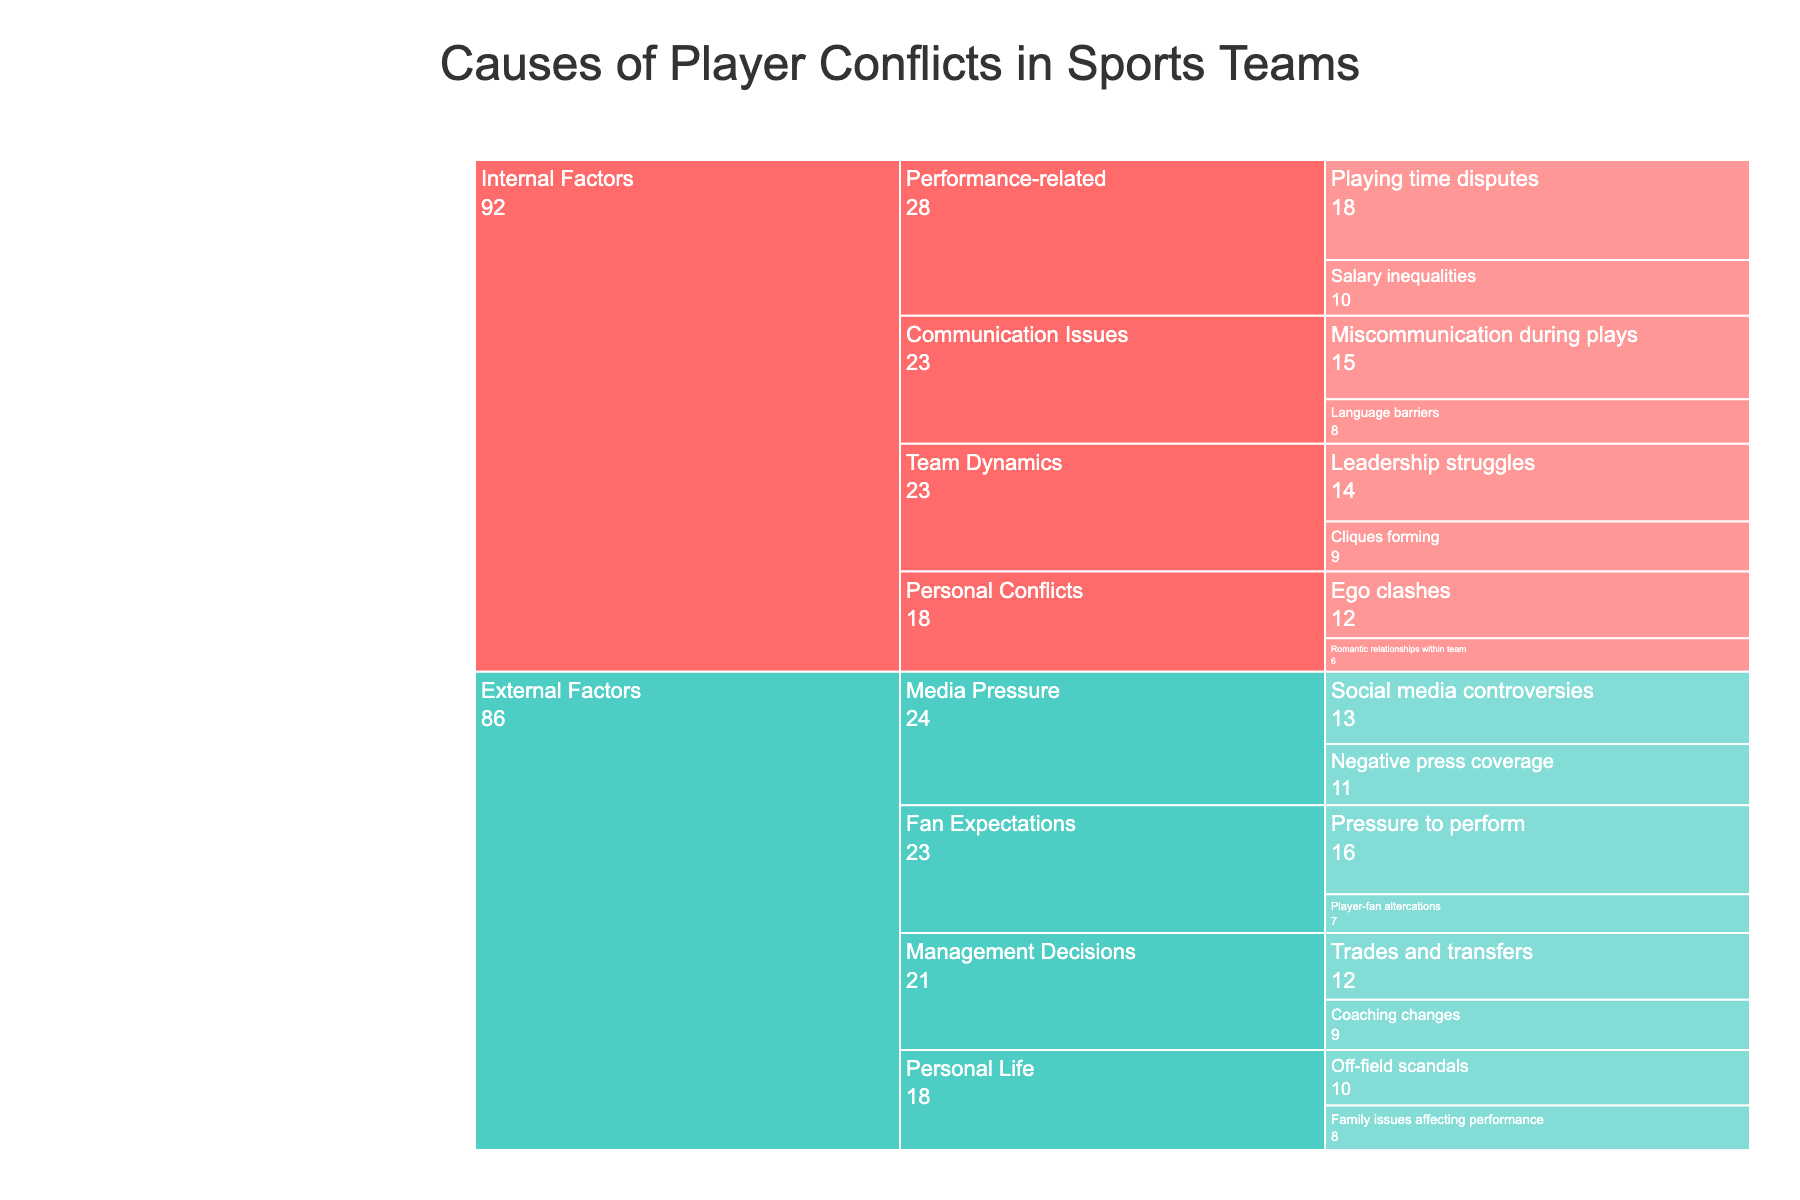What's the title of the figure? The title of the figure is located at the top and is one of the most obvious elements. By looking at the figure, you can easily read the title directly.
Answer: Causes of Player Conflicts in Sports Teams What color represents 'Internal Factors'? The color representation for 'Internal Factors' can be identified by looking at the sections of the icicle chart labeled 'Internal Factors'.
Answer: Red How many data points are under 'Personal Conflicts'? The data points under 'Personal Conflicts' can be counted by identifying the labeled sections and counting each one under that subcategory.
Answer: 2 What is the combined value of 'Non-Communication Issues'? First, identify and sum the values for 'Ego clashes' and 'Romantic relationships within the team'. 12 (Ego clashes) + 6 (Romantic relationships within the team).
Answer: 18 Which factor has the highest value in the chart? Look for the factor with the largest value displayed next to each label in the chart. 'Playing time disputes' under 'Performance-related' in 'Internal Factors' has the highest value.
Answer: Playing time disputes Which subcategory under 'External Factors' has the lowest average value of its factors? For each subcategory under 'External Factors', calculate the average by summing the values of the factors and dividing by the number of factors. Compare these averages to find the lowest. For 'Media Pressure': (11 + 13) / 2 = 12; For 'Fan Expectations': (16 + 7) / 2 = 11.5; For 'Management Decisions': (12 + 9) / 2 = 10.5; For 'Personal Life': (8 + 10) / 2 = 9. Comparing these averages: 12, 11.5, 10.5, 9, the lowest average value is 9 under 'Personal Life'.
Answer: Personal Life Which factor has more value: 'Playing time disputes' or 'Pressure to perform'? Identify the values of 'Playing time disputes' and 'Pressure to perform' and compare them directly. 'Playing time disputes' has a value of 18, and 'Pressure to perform' has a value of 16.
Answer: Playing time disputes What is the total value of factors under 'External Factors'? Sum the values of all factors categorized under 'External Factors': 11 + 13 + 16 + 7 + 12 + 9 + 8 + 10 = 86.
Answer: 86 How does the value of 'Language barriers' compare to 'Salary inequalities'? Compare the values listed on the chart: 'Language barriers' has a value of 8, and 'Salary inequalities' has a value of 10.
Answer: 'Language barriers' has a lower value than 'Salary inequalities' What subcategory under 'Internal Factors' contributes the most to player conflicts? For each subcategory under 'Internal Factors', sum the values of its factors and compare them. 'Communication Issues': 15+8 = 23; 'Personal Conflicts': 12+6 = 18; 'Performance-related': 18+10 = 28; 'Team Dynamics': 14+9 = 23. The subcategory 'Performance-related' has the highest total value of 28.
Answer: Performance-related 